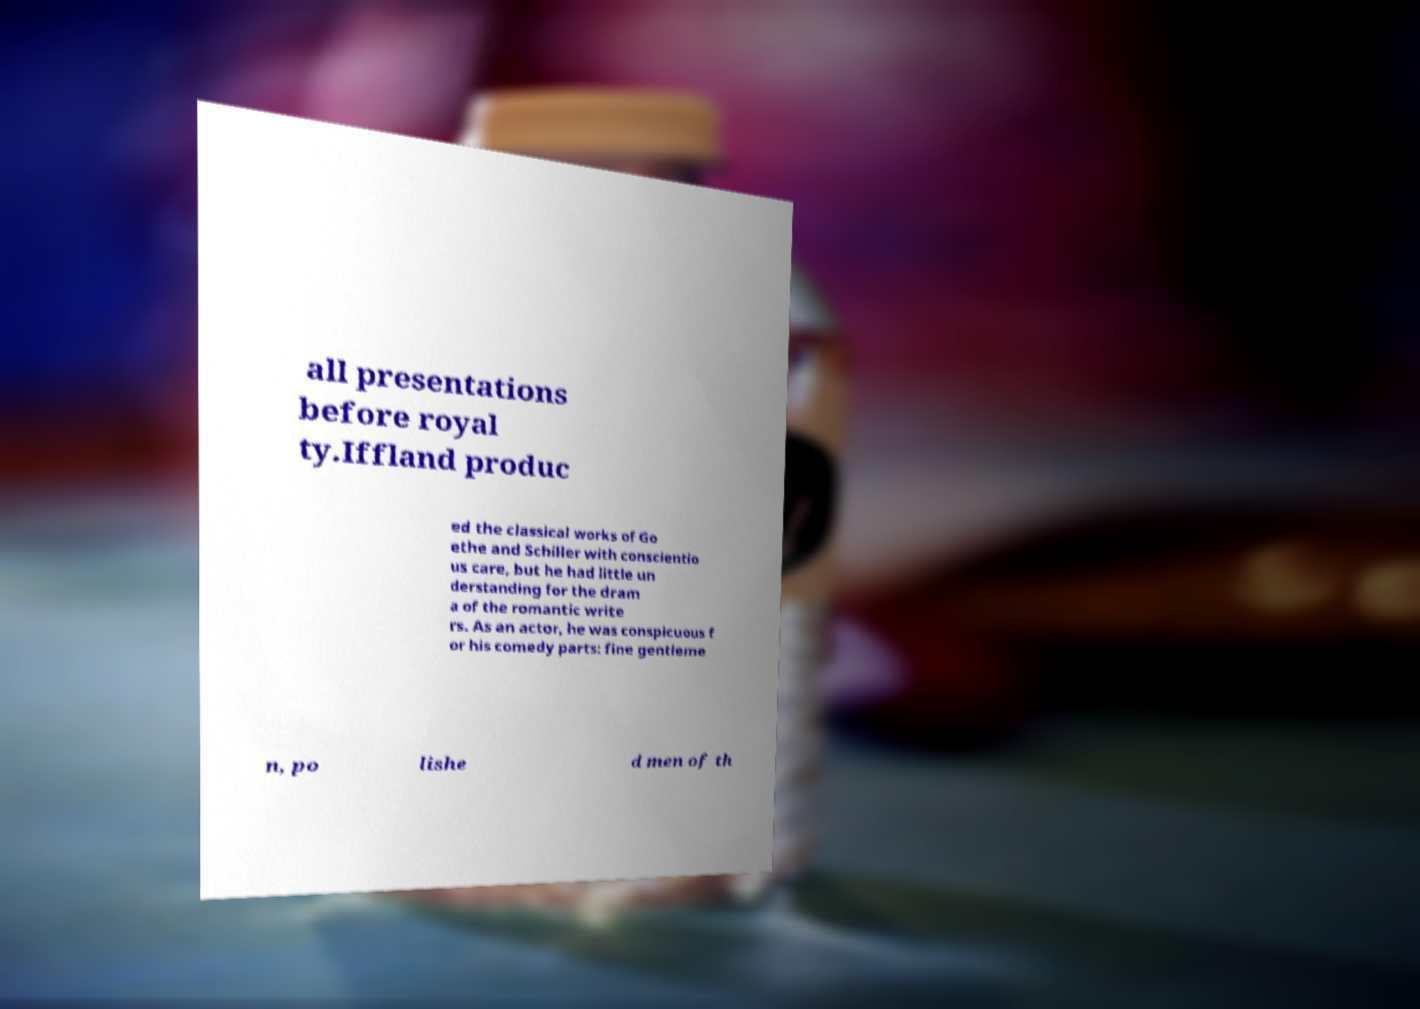Please identify and transcribe the text found in this image. all presentations before royal ty.Iffland produc ed the classical works of Go ethe and Schiller with conscientio us care, but he had little un derstanding for the dram a of the romantic write rs. As an actor, he was conspicuous f or his comedy parts: fine gentleme n, po lishe d men of th 